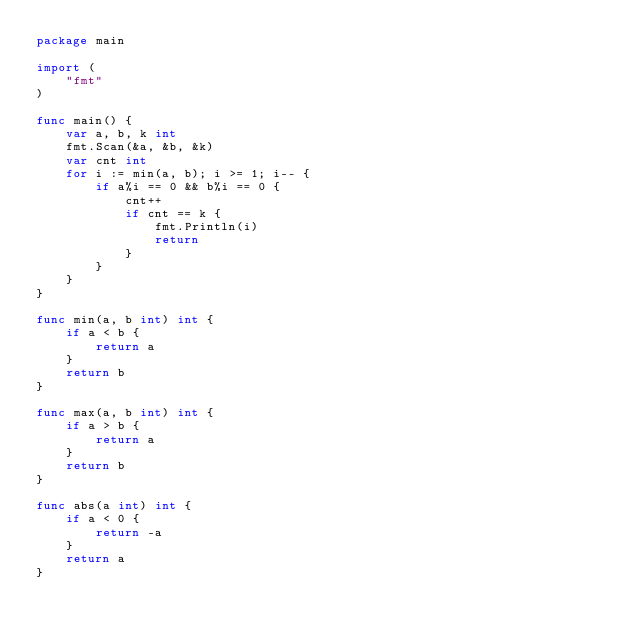Convert code to text. <code><loc_0><loc_0><loc_500><loc_500><_Go_>package main

import (
	"fmt"
)

func main() {
	var a, b, k int
	fmt.Scan(&a, &b, &k)
	var cnt int
	for i := min(a, b); i >= 1; i-- {
		if a%i == 0 && b%i == 0 {
			cnt++
			if cnt == k {
				fmt.Println(i)
				return
			}
		}
	}
}

func min(a, b int) int {
	if a < b {
		return a
	}
	return b
}

func max(a, b int) int {
	if a > b {
		return a
	}
	return b
}

func abs(a int) int {
	if a < 0 {
		return -a
	}
	return a
}
</code> 